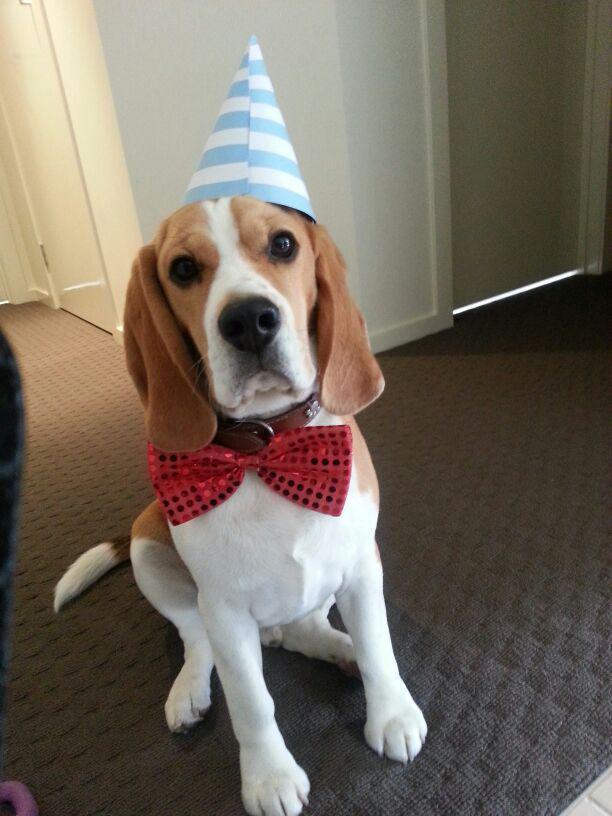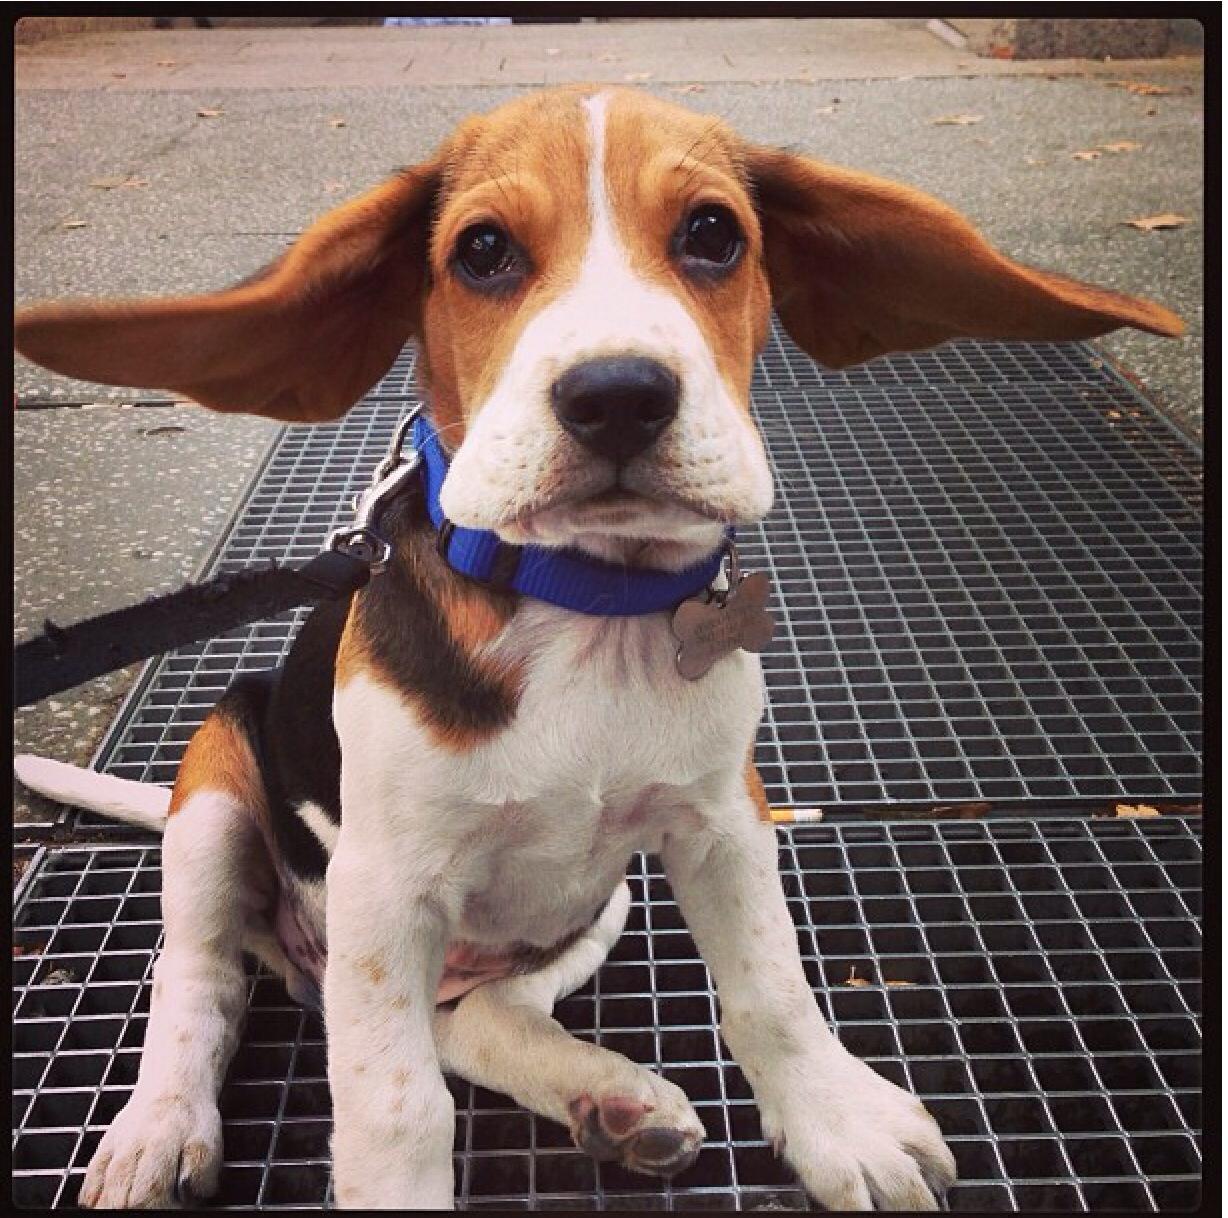The first image is the image on the left, the second image is the image on the right. Given the left and right images, does the statement "One image contains one dog, which wears a blue collar, and the other image features a dog wearing a costume that includes a hat and something around its neck." hold true? Answer yes or no. Yes. The first image is the image on the left, the second image is the image on the right. Evaluate the accuracy of this statement regarding the images: "A dog in one of the images is wearing something on top of its head.". Is it true? Answer yes or no. Yes. 